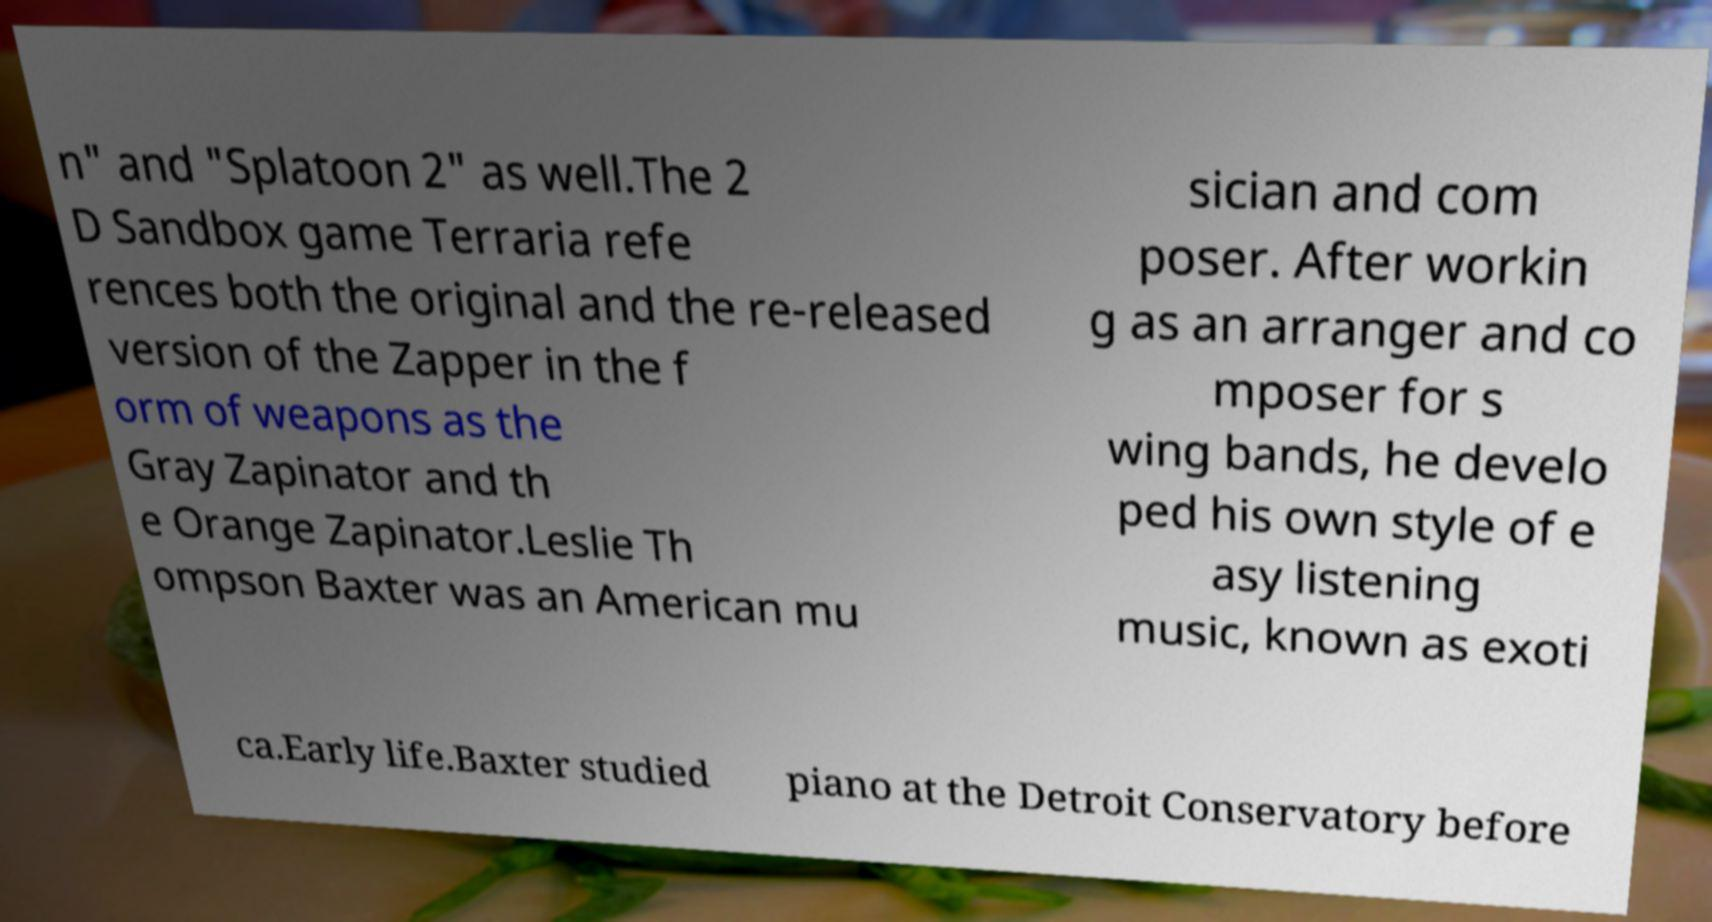Can you accurately transcribe the text from the provided image for me? n" and "Splatoon 2" as well.The 2 D Sandbox game Terraria refe rences both the original and the re-released version of the Zapper in the f orm of weapons as the Gray Zapinator and th e Orange Zapinator.Leslie Th ompson Baxter was an American mu sician and com poser. After workin g as an arranger and co mposer for s wing bands, he develo ped his own style of e asy listening music, known as exoti ca.Early life.Baxter studied piano at the Detroit Conservatory before 